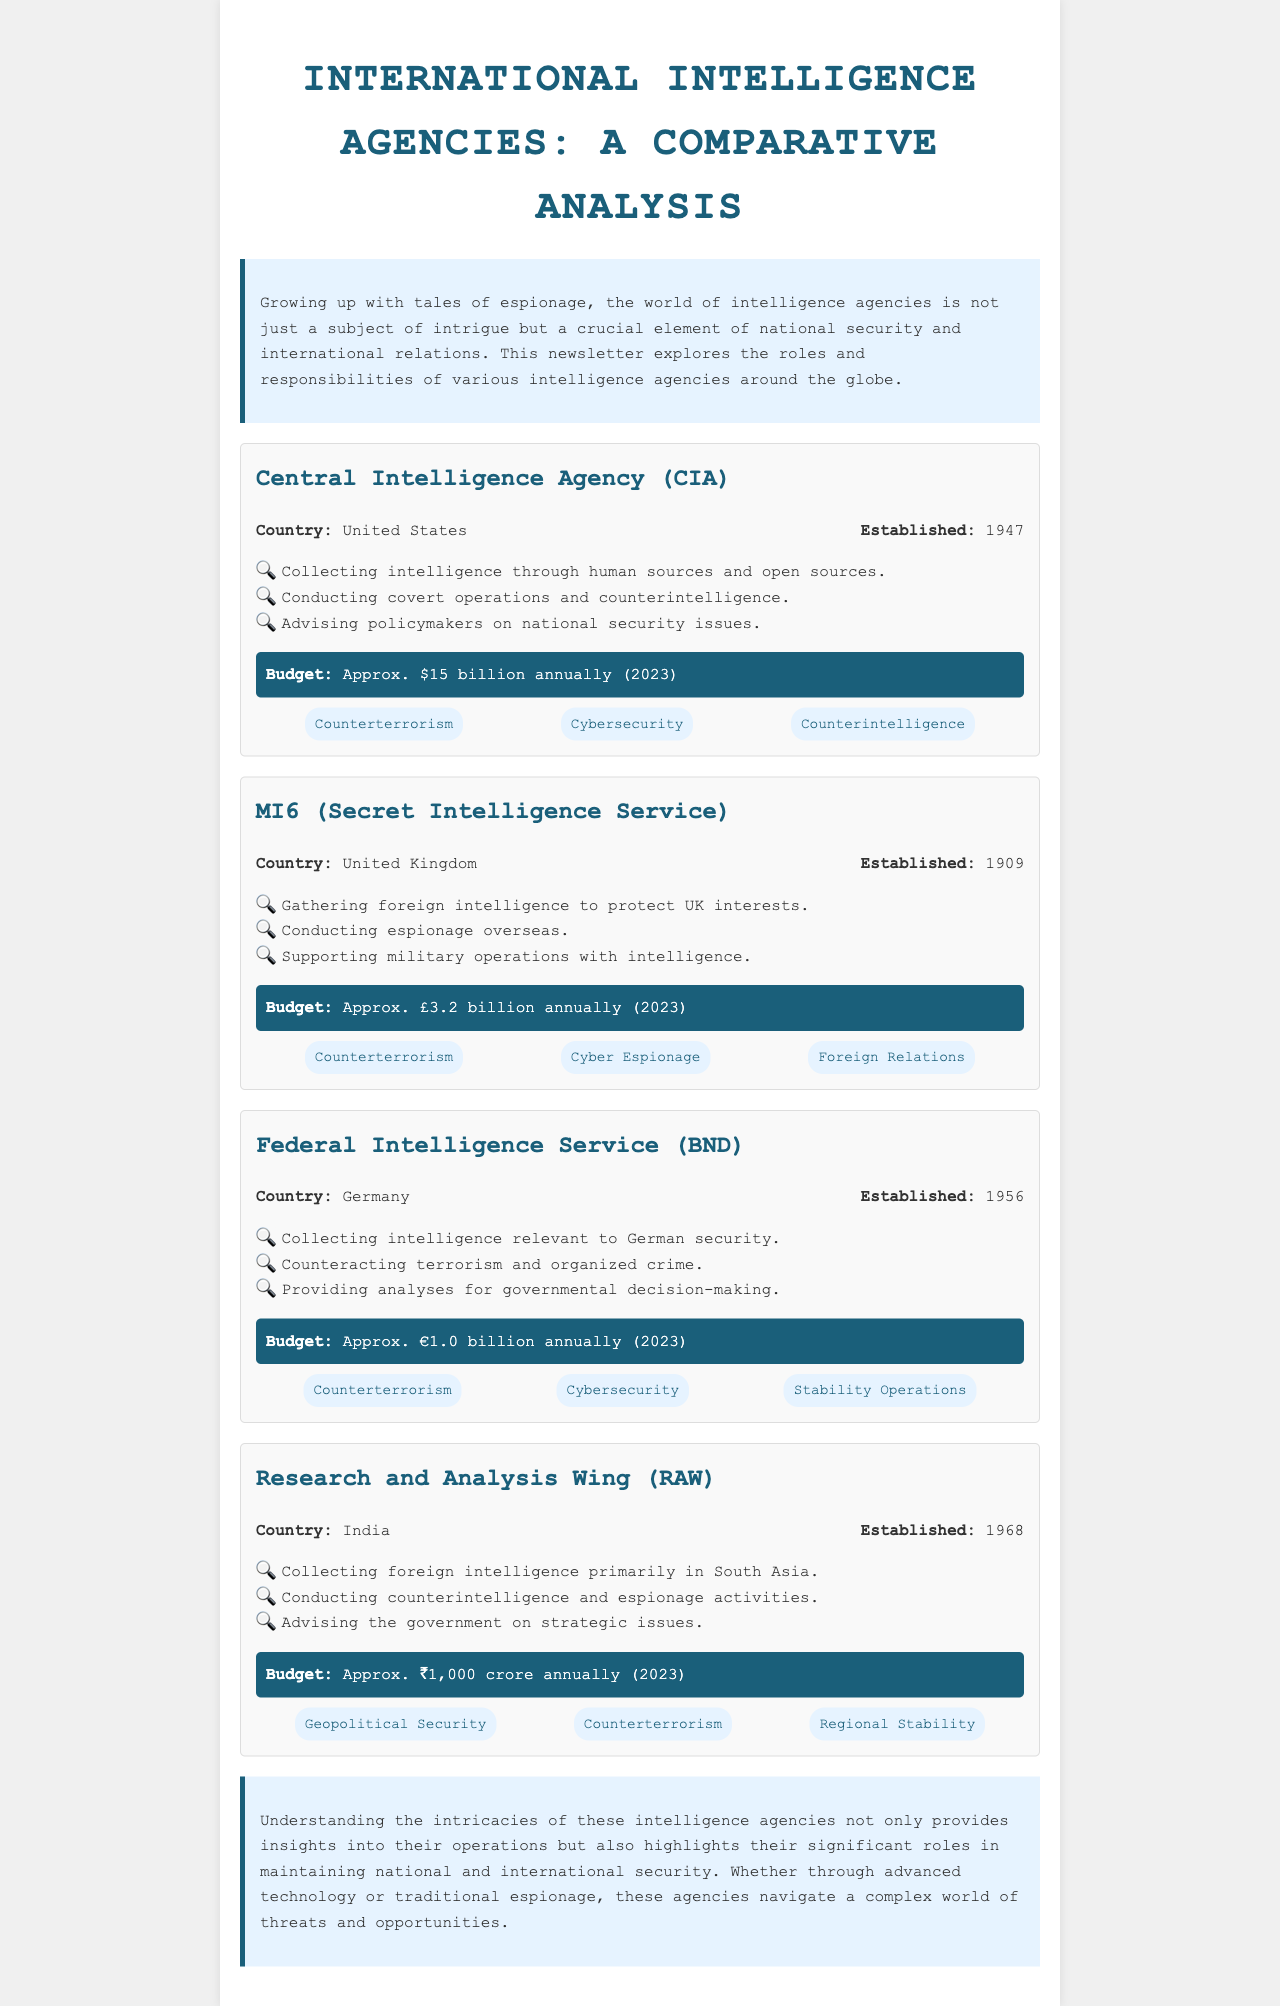What is the established year of the CIA? The CIA was established in 1947.
Answer: 1947 What is the annual budget of MI6? MI6's budget is approximately £3.2 billion annually (2023).
Answer: £3.2 billion Which agency is responsible for geopolitical security in India? The Research and Analysis Wing (RAW) is responsible for geopolitical security in India.
Answer: RAW What are the primary focus areas of BND? The primary focus areas of BND include Counterterrorism, Cybersecurity, and Stability Operations.
Answer: Counterterrorism, Cybersecurity, Stability Operations In which country is the Federal Intelligence Service located? The Federal Intelligence Service (BND) is located in Germany.
Answer: Germany How many focus areas does the CIA have listed? The CIA has three focus areas listed: Counterterrorism, Cybersecurity, and Counterintelligence.
Answer: Three Which intelligence agency was established most recently? The agency established most recently among the listed ones is the CIA in 1947.
Answer: CIA What are the names of the agencies mentioned in the document? The agencies mentioned are CIA, MI6, BND, and RAW.
Answer: CIA, MI6, BND, RAW Which agency advises policymakers on national security issues? The CIA advises policymakers on national security issues.
Answer: CIA 